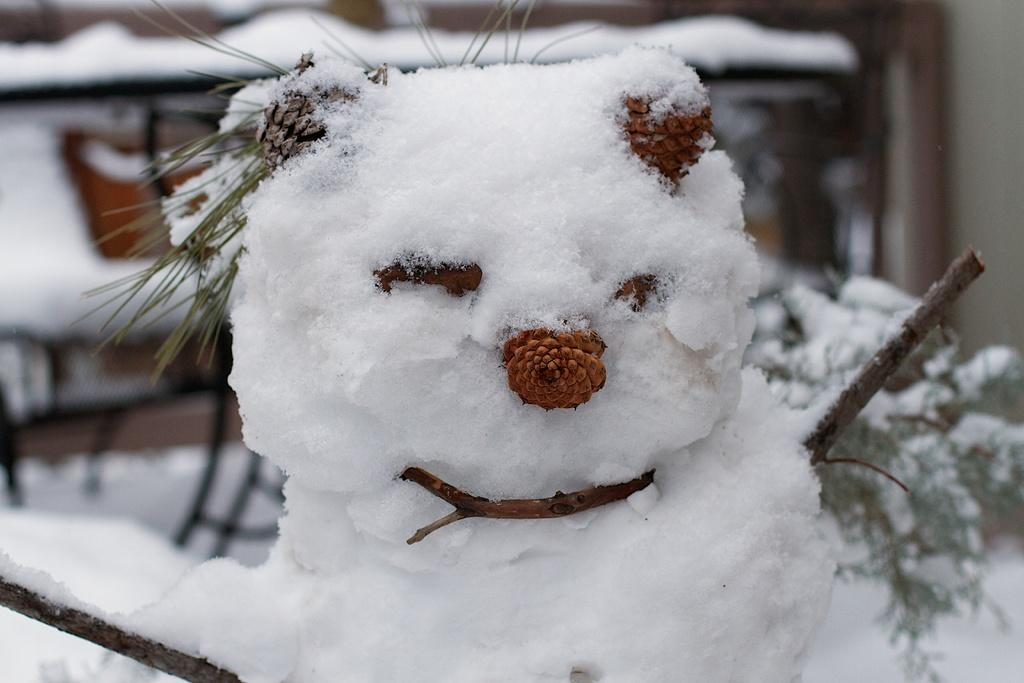What type of doll is in the image? There is a snow-made doll in the image. What can be seen with the doll in the image? There are costumes for the doll in the image. What furniture is visible in the background of the image? There are chairs and a table in the background of the image. What is on the table in the image? Snow is visible on the table. What type of approval is being sought for the toy in the image? There is no toy present in the image, only a snow-made doll. What type of clouds can be seen in the image? There are no clouds visible in the image; it is focused on the snow-made doll and its surroundings. 